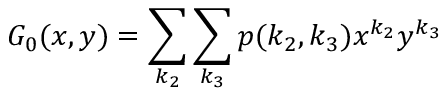<formula> <loc_0><loc_0><loc_500><loc_500>G _ { 0 } ( x , y ) = \sum _ { k _ { 2 } } \sum _ { k _ { 3 } } p ( k _ { 2 } , k _ { 3 } ) x ^ { k _ { 2 } } y ^ { k _ { 3 } }</formula> 